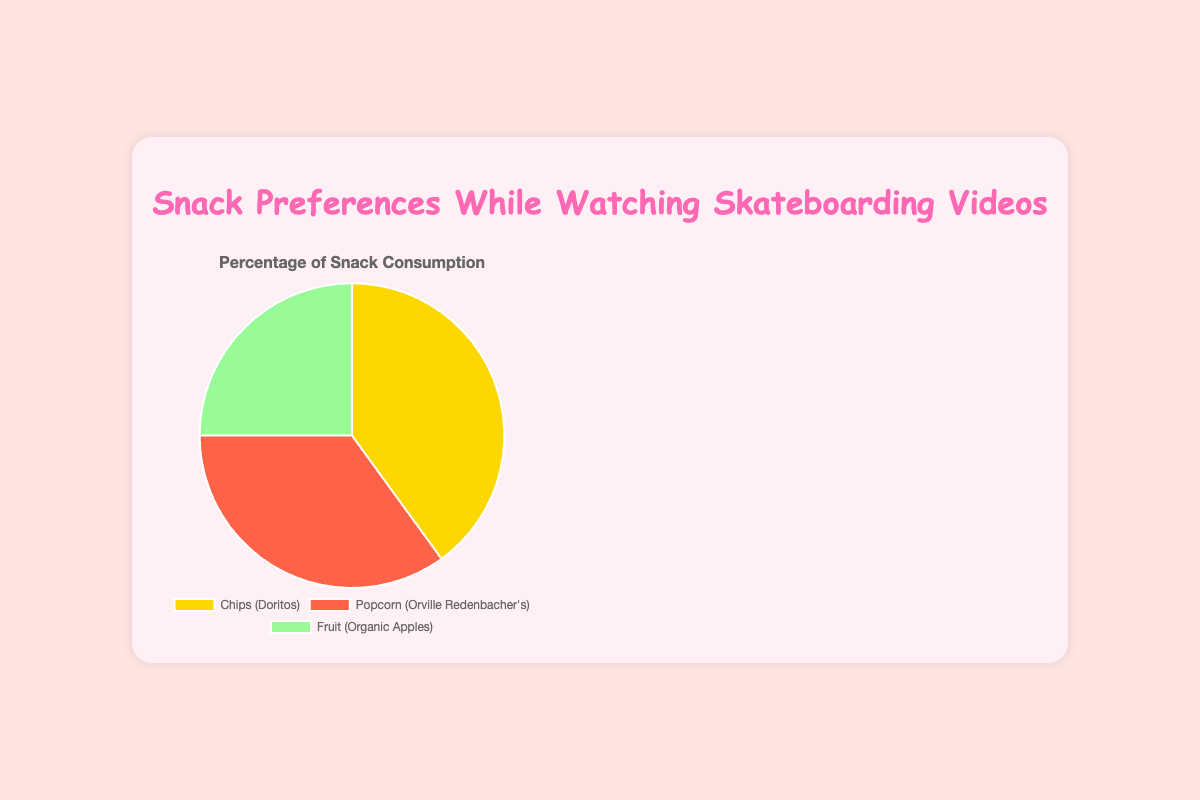What snack accounts for the highest percentage consumption while watching skateboarding videos? The figure shows that Chips (Doritos) have the largest portion of the pie chart.
Answer: Chips Which snack accounts for the smallest percentage consumption while watching skateboarding videos? The figure shows that Fruit (Organic Apples) have the smallest portion of the pie chart.
Answer: Fruit How much greater is the percentage of chips consumed compared to fruit? The percentage of chips consumed is 40%, while fruit is 25%. The difference is 40% - 25% = 15%.
Answer: 15% How does the percentage of popcorn consumed compare to that of chips? Chips account for 40% and popcorn for 35%. Popcorn consumption is 5% less than chips.
Answer: 5% less What is the combined percentage of popcorn and fruit consumption? Popcorn accounts for 35% and fruit for 25%. The combined percentage is 35% + 25% = 60%.
Answer: 60% Which snack has the highest consumption rating? The ratings are displayed on the pie chart. Popcorn (Orville Redenbacher's) has the highest rating of 4.8.
Answer: Popcorn If the pie chart's color for fruit is light green, what color represents chips? The description states that chips are represented in yellow.
Answer: Yellow What is the average percentage consumption of all three snacks? The percentages are 40% for chips, 35% for popcorn, and 25% for fruit. The average is (40 + 35 + 25) / 3 = 33.33%.
Answer: 33.33% Is there a snack type that is consumed more than double any other? Chips at 40% is not more than double of popcorn at 35%. Popcorn at 35% is not more than double of fruit at 25%.
Answer: No What type of snack is represented by the red portion of the pie chart? The color red is associated with popcorn in the chart description.
Answer: Popcorn 